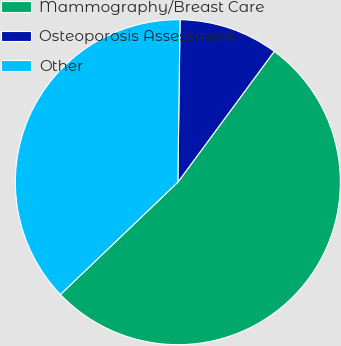Convert chart. <chart><loc_0><loc_0><loc_500><loc_500><pie_chart><fcel>Mammography/Breast Care<fcel>Osteoporosis Assessment<fcel>Other<nl><fcel>52.75%<fcel>9.89%<fcel>37.36%<nl></chart> 